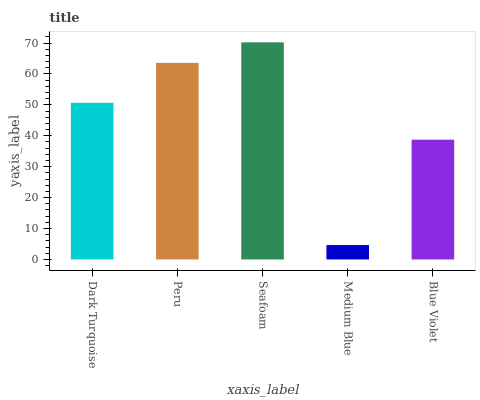Is Medium Blue the minimum?
Answer yes or no. Yes. Is Seafoam the maximum?
Answer yes or no. Yes. Is Peru the minimum?
Answer yes or no. No. Is Peru the maximum?
Answer yes or no. No. Is Peru greater than Dark Turquoise?
Answer yes or no. Yes. Is Dark Turquoise less than Peru?
Answer yes or no. Yes. Is Dark Turquoise greater than Peru?
Answer yes or no. No. Is Peru less than Dark Turquoise?
Answer yes or no. No. Is Dark Turquoise the high median?
Answer yes or no. Yes. Is Dark Turquoise the low median?
Answer yes or no. Yes. Is Peru the high median?
Answer yes or no. No. Is Peru the low median?
Answer yes or no. No. 